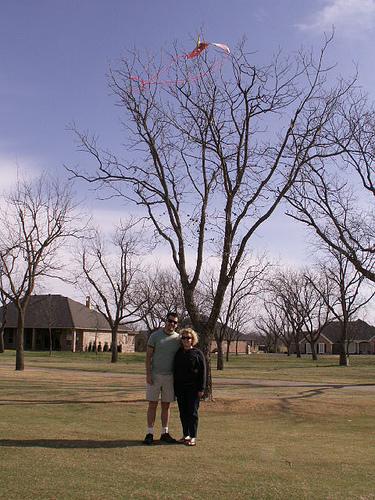What is in the tree?
Give a very brief answer. Kite. How many people?
Concise answer only. 2. What animal is in the picture?
Short answer required. None. Does the grass need to be watered?
Be succinct. Yes. 